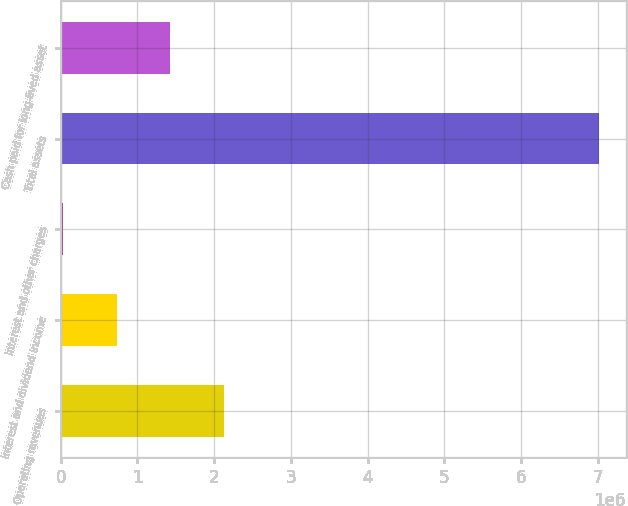<chart> <loc_0><loc_0><loc_500><loc_500><bar_chart><fcel>Operating revenues<fcel>Interest and dividend income<fcel>Interest and other charges<fcel>Total assets<fcel>Cash paid for long-lived asset<nl><fcel>2.12866e+06<fcel>732713<fcel>34738<fcel>7.01448e+06<fcel>1.43069e+06<nl></chart> 